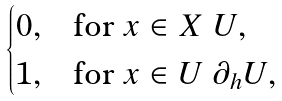Convert formula to latex. <formula><loc_0><loc_0><loc_500><loc_500>\begin{cases} 0 , & \text {for} \ x \in X \ U , \\ 1 , & \text {for} \ x \in U \ \partial _ { h } U , \end{cases}</formula> 